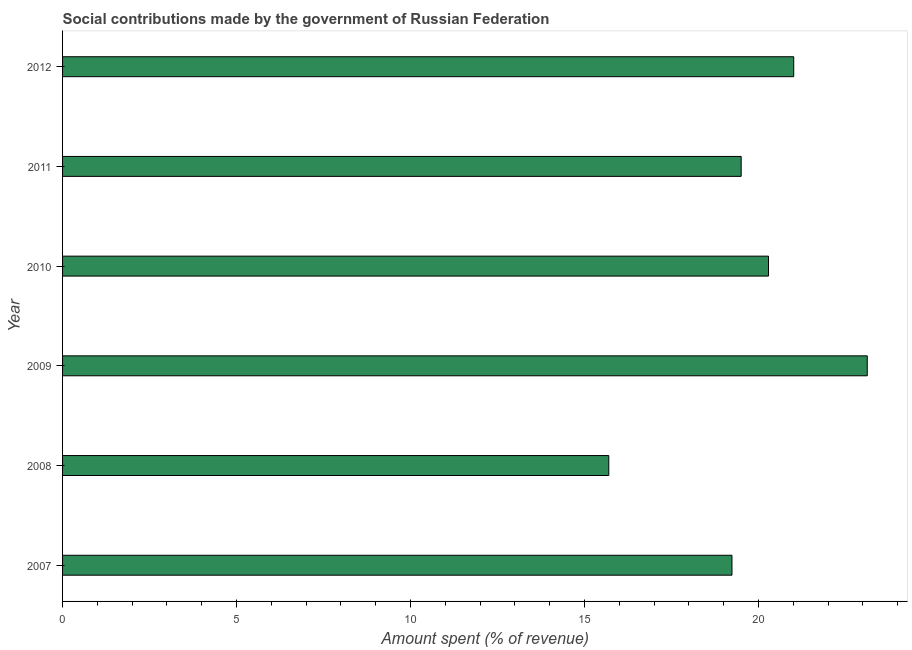Does the graph contain any zero values?
Ensure brevity in your answer.  No. Does the graph contain grids?
Make the answer very short. No. What is the title of the graph?
Provide a succinct answer. Social contributions made by the government of Russian Federation. What is the label or title of the X-axis?
Offer a terse response. Amount spent (% of revenue). What is the label or title of the Y-axis?
Keep it short and to the point. Year. What is the amount spent in making social contributions in 2007?
Provide a short and direct response. 19.24. Across all years, what is the maximum amount spent in making social contributions?
Provide a short and direct response. 23.13. Across all years, what is the minimum amount spent in making social contributions?
Your response must be concise. 15.7. What is the sum of the amount spent in making social contributions?
Give a very brief answer. 118.87. What is the difference between the amount spent in making social contributions in 2007 and 2012?
Your answer should be compact. -1.77. What is the average amount spent in making social contributions per year?
Offer a very short reply. 19.81. What is the median amount spent in making social contributions?
Your response must be concise. 19.9. In how many years, is the amount spent in making social contributions greater than 5 %?
Ensure brevity in your answer.  6. Do a majority of the years between 2010 and 2012 (inclusive) have amount spent in making social contributions greater than 1 %?
Give a very brief answer. Yes. What is the ratio of the amount spent in making social contributions in 2009 to that in 2010?
Provide a short and direct response. 1.14. Is the difference between the amount spent in making social contributions in 2011 and 2012 greater than the difference between any two years?
Offer a terse response. No. What is the difference between the highest and the second highest amount spent in making social contributions?
Provide a succinct answer. 2.11. Is the sum of the amount spent in making social contributions in 2007 and 2011 greater than the maximum amount spent in making social contributions across all years?
Keep it short and to the point. Yes. What is the difference between the highest and the lowest amount spent in making social contributions?
Provide a succinct answer. 7.43. How many years are there in the graph?
Your response must be concise. 6. What is the difference between two consecutive major ticks on the X-axis?
Keep it short and to the point. 5. Are the values on the major ticks of X-axis written in scientific E-notation?
Offer a very short reply. No. What is the Amount spent (% of revenue) in 2007?
Make the answer very short. 19.24. What is the Amount spent (% of revenue) in 2008?
Your response must be concise. 15.7. What is the Amount spent (% of revenue) in 2009?
Offer a terse response. 23.13. What is the Amount spent (% of revenue) of 2010?
Give a very brief answer. 20.29. What is the Amount spent (% of revenue) in 2011?
Your response must be concise. 19.5. What is the Amount spent (% of revenue) of 2012?
Ensure brevity in your answer.  21.01. What is the difference between the Amount spent (% of revenue) in 2007 and 2008?
Give a very brief answer. 3.54. What is the difference between the Amount spent (% of revenue) in 2007 and 2009?
Your answer should be very brief. -3.89. What is the difference between the Amount spent (% of revenue) in 2007 and 2010?
Keep it short and to the point. -1.05. What is the difference between the Amount spent (% of revenue) in 2007 and 2011?
Provide a short and direct response. -0.26. What is the difference between the Amount spent (% of revenue) in 2007 and 2012?
Your answer should be compact. -1.77. What is the difference between the Amount spent (% of revenue) in 2008 and 2009?
Your answer should be very brief. -7.43. What is the difference between the Amount spent (% of revenue) in 2008 and 2010?
Ensure brevity in your answer.  -4.59. What is the difference between the Amount spent (% of revenue) in 2008 and 2011?
Your answer should be very brief. -3.8. What is the difference between the Amount spent (% of revenue) in 2008 and 2012?
Make the answer very short. -5.31. What is the difference between the Amount spent (% of revenue) in 2009 and 2010?
Your answer should be compact. 2.84. What is the difference between the Amount spent (% of revenue) in 2009 and 2011?
Offer a very short reply. 3.62. What is the difference between the Amount spent (% of revenue) in 2009 and 2012?
Keep it short and to the point. 2.11. What is the difference between the Amount spent (% of revenue) in 2010 and 2011?
Your answer should be compact. 0.78. What is the difference between the Amount spent (% of revenue) in 2010 and 2012?
Keep it short and to the point. -0.73. What is the difference between the Amount spent (% of revenue) in 2011 and 2012?
Make the answer very short. -1.51. What is the ratio of the Amount spent (% of revenue) in 2007 to that in 2008?
Give a very brief answer. 1.23. What is the ratio of the Amount spent (% of revenue) in 2007 to that in 2009?
Your answer should be compact. 0.83. What is the ratio of the Amount spent (% of revenue) in 2007 to that in 2010?
Your answer should be very brief. 0.95. What is the ratio of the Amount spent (% of revenue) in 2007 to that in 2011?
Make the answer very short. 0.99. What is the ratio of the Amount spent (% of revenue) in 2007 to that in 2012?
Keep it short and to the point. 0.92. What is the ratio of the Amount spent (% of revenue) in 2008 to that in 2009?
Provide a short and direct response. 0.68. What is the ratio of the Amount spent (% of revenue) in 2008 to that in 2010?
Your response must be concise. 0.77. What is the ratio of the Amount spent (% of revenue) in 2008 to that in 2011?
Provide a short and direct response. 0.81. What is the ratio of the Amount spent (% of revenue) in 2008 to that in 2012?
Your response must be concise. 0.75. What is the ratio of the Amount spent (% of revenue) in 2009 to that in 2010?
Your answer should be very brief. 1.14. What is the ratio of the Amount spent (% of revenue) in 2009 to that in 2011?
Your response must be concise. 1.19. What is the ratio of the Amount spent (% of revenue) in 2009 to that in 2012?
Offer a terse response. 1.1. What is the ratio of the Amount spent (% of revenue) in 2011 to that in 2012?
Make the answer very short. 0.93. 